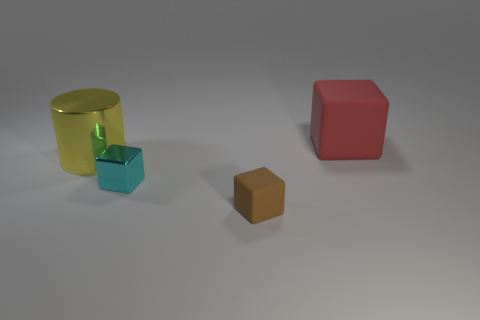There is a thing right of the brown matte thing; is its shape the same as the cyan metallic thing?
Provide a succinct answer. Yes. Is the number of yellow metal cylinders that are right of the small metallic object greater than the number of big cyan things?
Offer a very short reply. No. Is the color of the metallic thing that is behind the tiny metallic block the same as the tiny metal object?
Your response must be concise. No. Is there any other thing that has the same color as the large rubber block?
Keep it short and to the point. No. The rubber thing in front of the large cube that is to the right of the rubber block that is in front of the red rubber thing is what color?
Offer a terse response. Brown. Does the brown rubber cube have the same size as the yellow metallic object?
Keep it short and to the point. No. What number of red things are the same size as the red cube?
Give a very brief answer. 0. Is the large thing behind the big yellow shiny cylinder made of the same material as the big yellow cylinder on the left side of the cyan thing?
Offer a very short reply. No. Are there any other things that are the same shape as the brown thing?
Your response must be concise. Yes. The big rubber object is what color?
Keep it short and to the point. Red. 